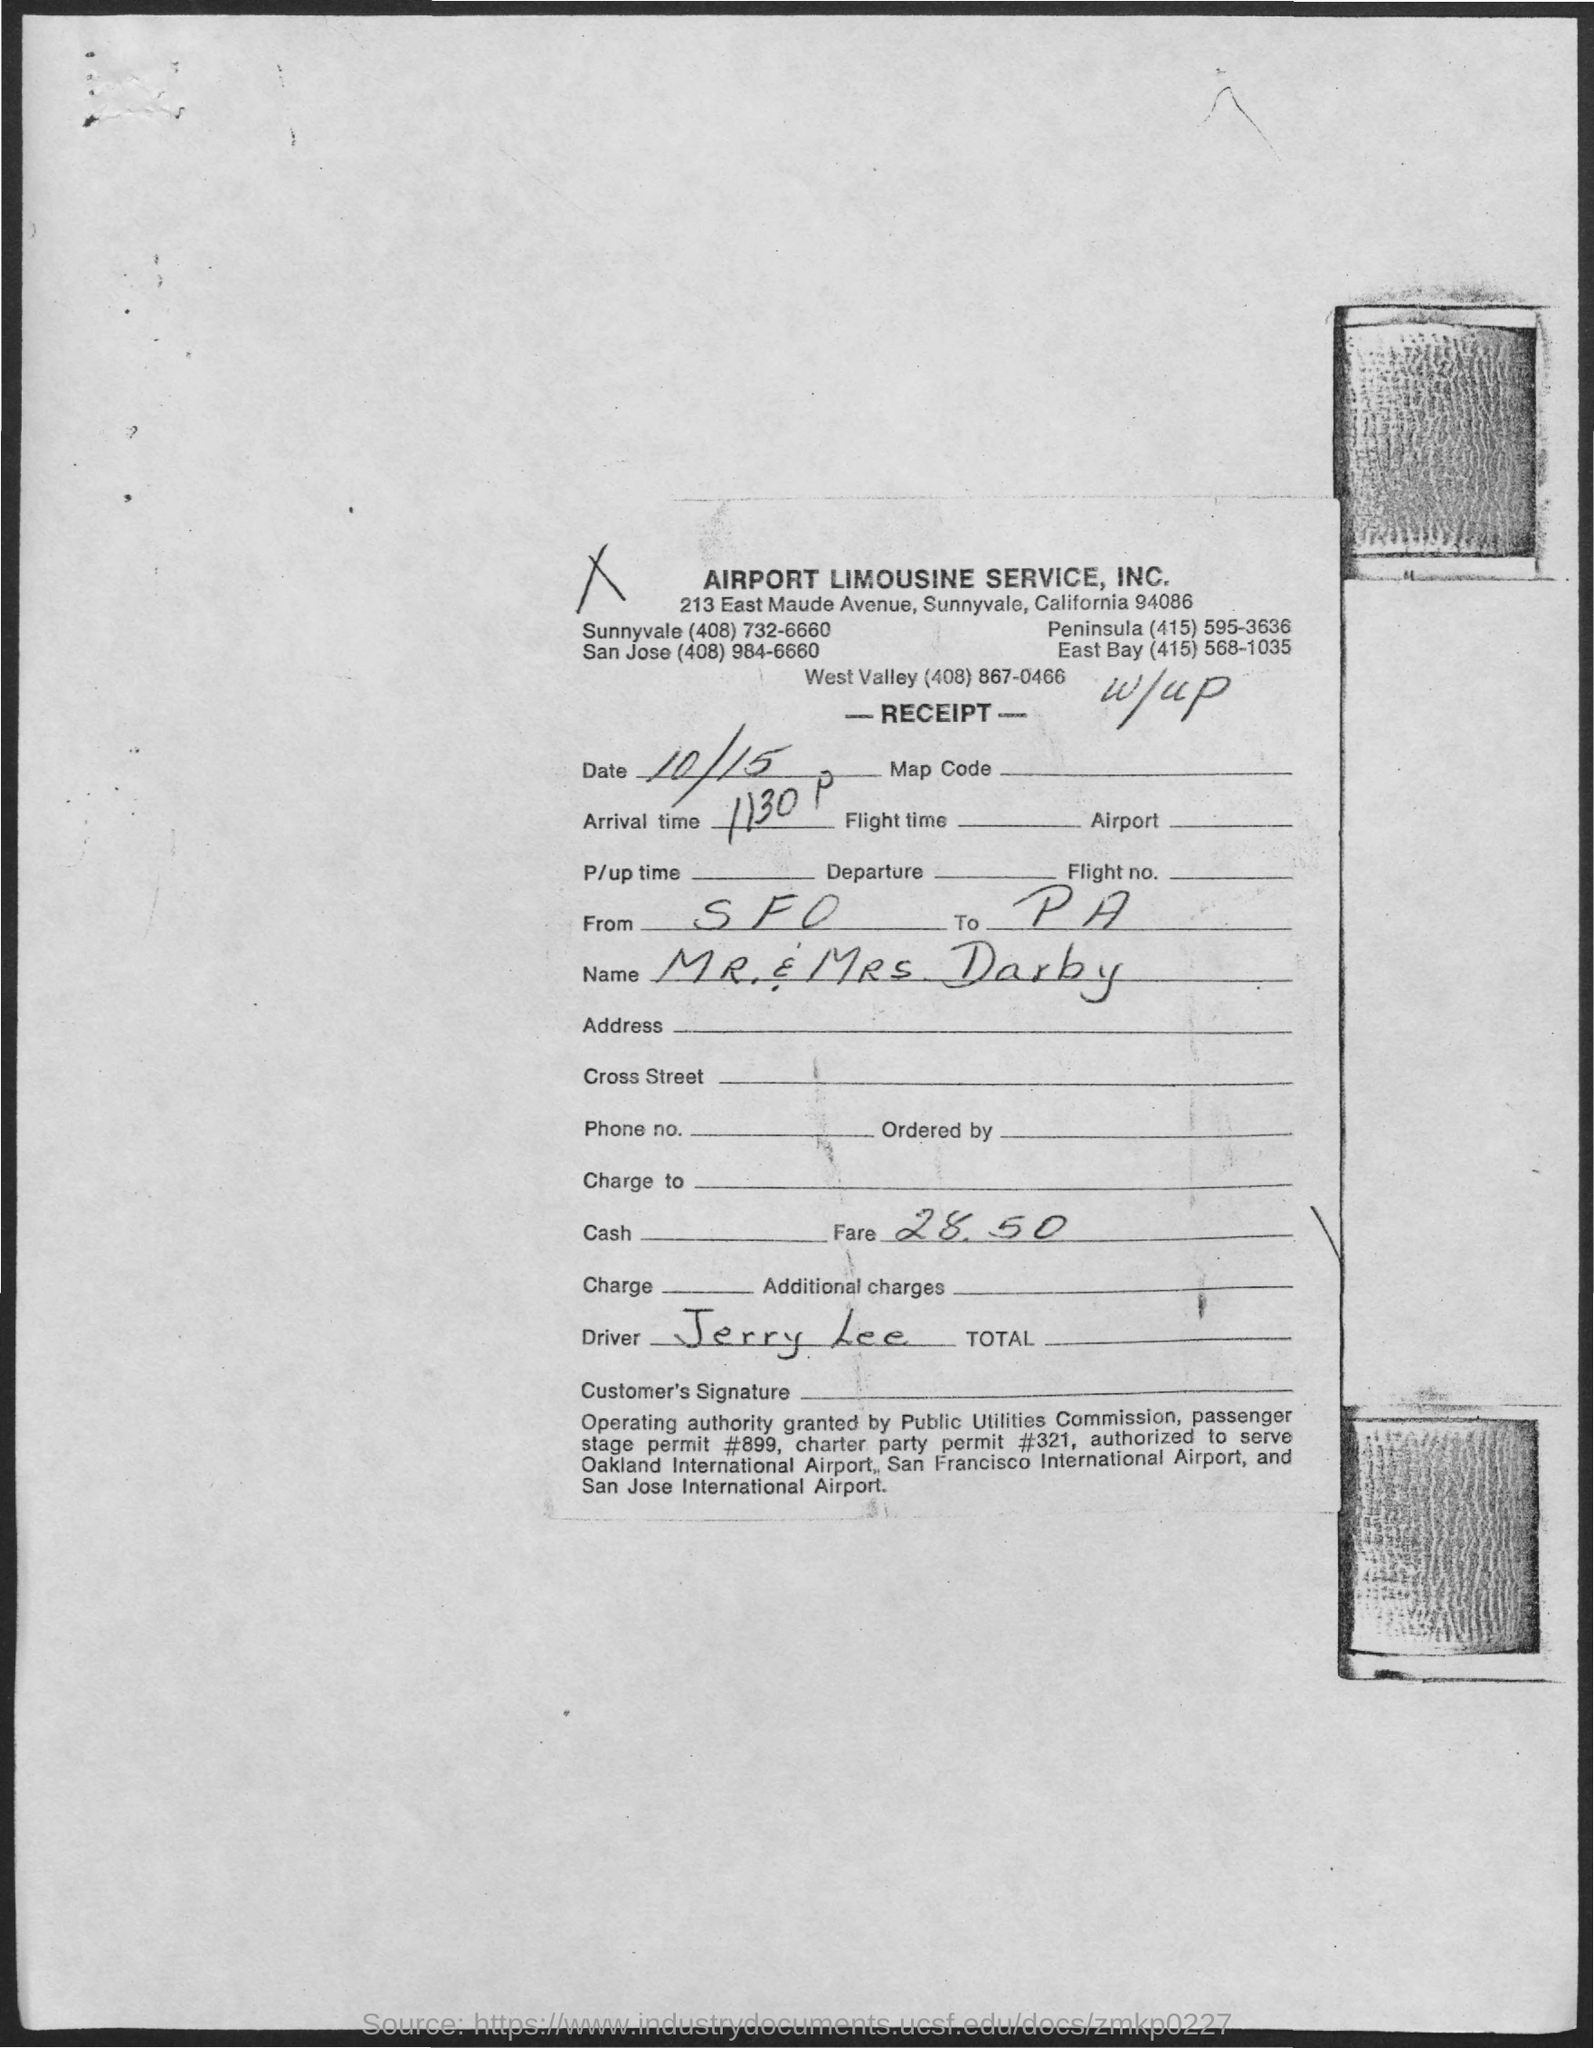Indicate a few pertinent items in this graphic. The traveller's name is MR & MRS DARBY. The organization name is Airport Limousine Service, Inc. The fare amount is 28.50. 